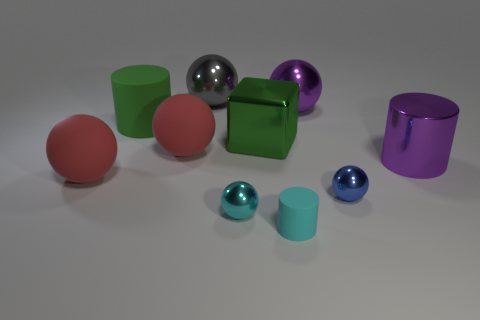Are there fewer cyan things that are behind the tiny cyan rubber thing than large green cylinders behind the green rubber cylinder?
Offer a very short reply. No. Do the blue sphere and the cube behind the big metallic cylinder have the same material?
Make the answer very short. Yes. Is there any other thing that is the same material as the block?
Your answer should be very brief. Yes. Is the number of big metallic things greater than the number of cyan objects?
Your response must be concise. Yes. There is a green thing that is left of the large matte thing that is on the right side of the large green object left of the metallic block; what shape is it?
Keep it short and to the point. Cylinder. Are the object left of the large green matte thing and the small cyan object left of the tiny cyan rubber thing made of the same material?
Offer a very short reply. No. What is the shape of the green object that is the same material as the small blue thing?
Provide a succinct answer. Cube. Are there any other things that have the same color as the tiny rubber cylinder?
Offer a very short reply. Yes. How many purple objects are there?
Provide a succinct answer. 2. There is a red thing behind the object that is on the right side of the blue metal sphere; what is its material?
Give a very brief answer. Rubber. 